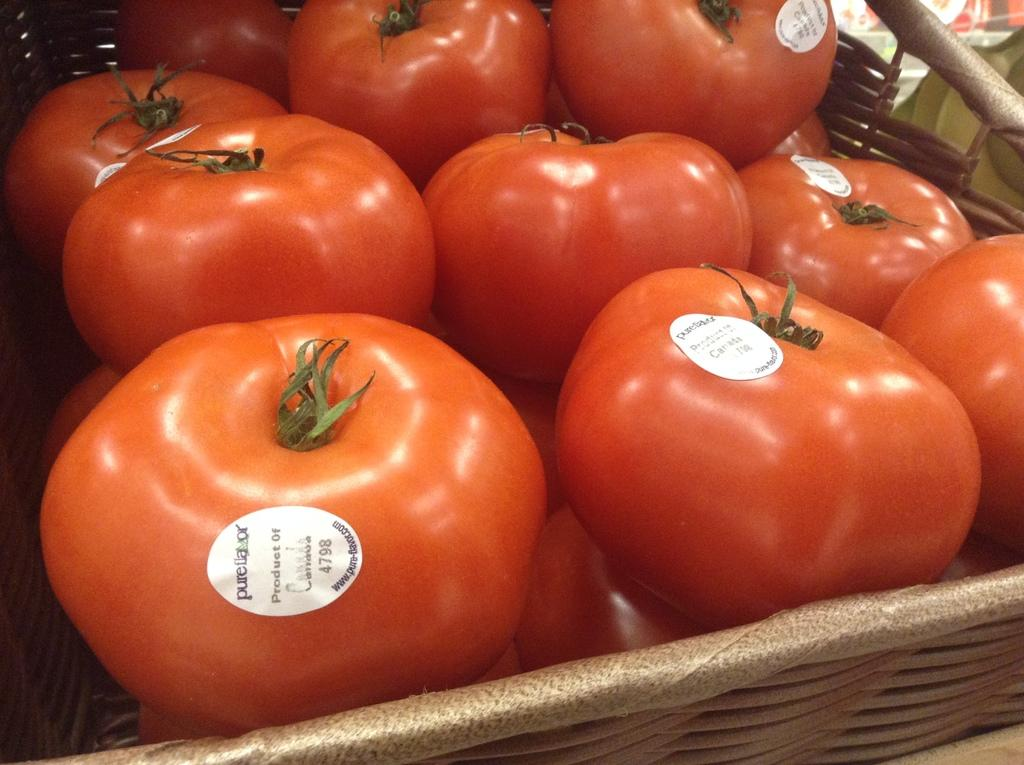What object is present in the image that can hold items? There is a basket in the image. What is inside the basket? The basket contains tomatoes. Are there any additional details about the tomatoes? Yes, there are labels on the tomatoes. What type of silk can be seen draped over the tomatoes in the image? There is no silk present in the image; it features a basket of tomatoes with labels. 